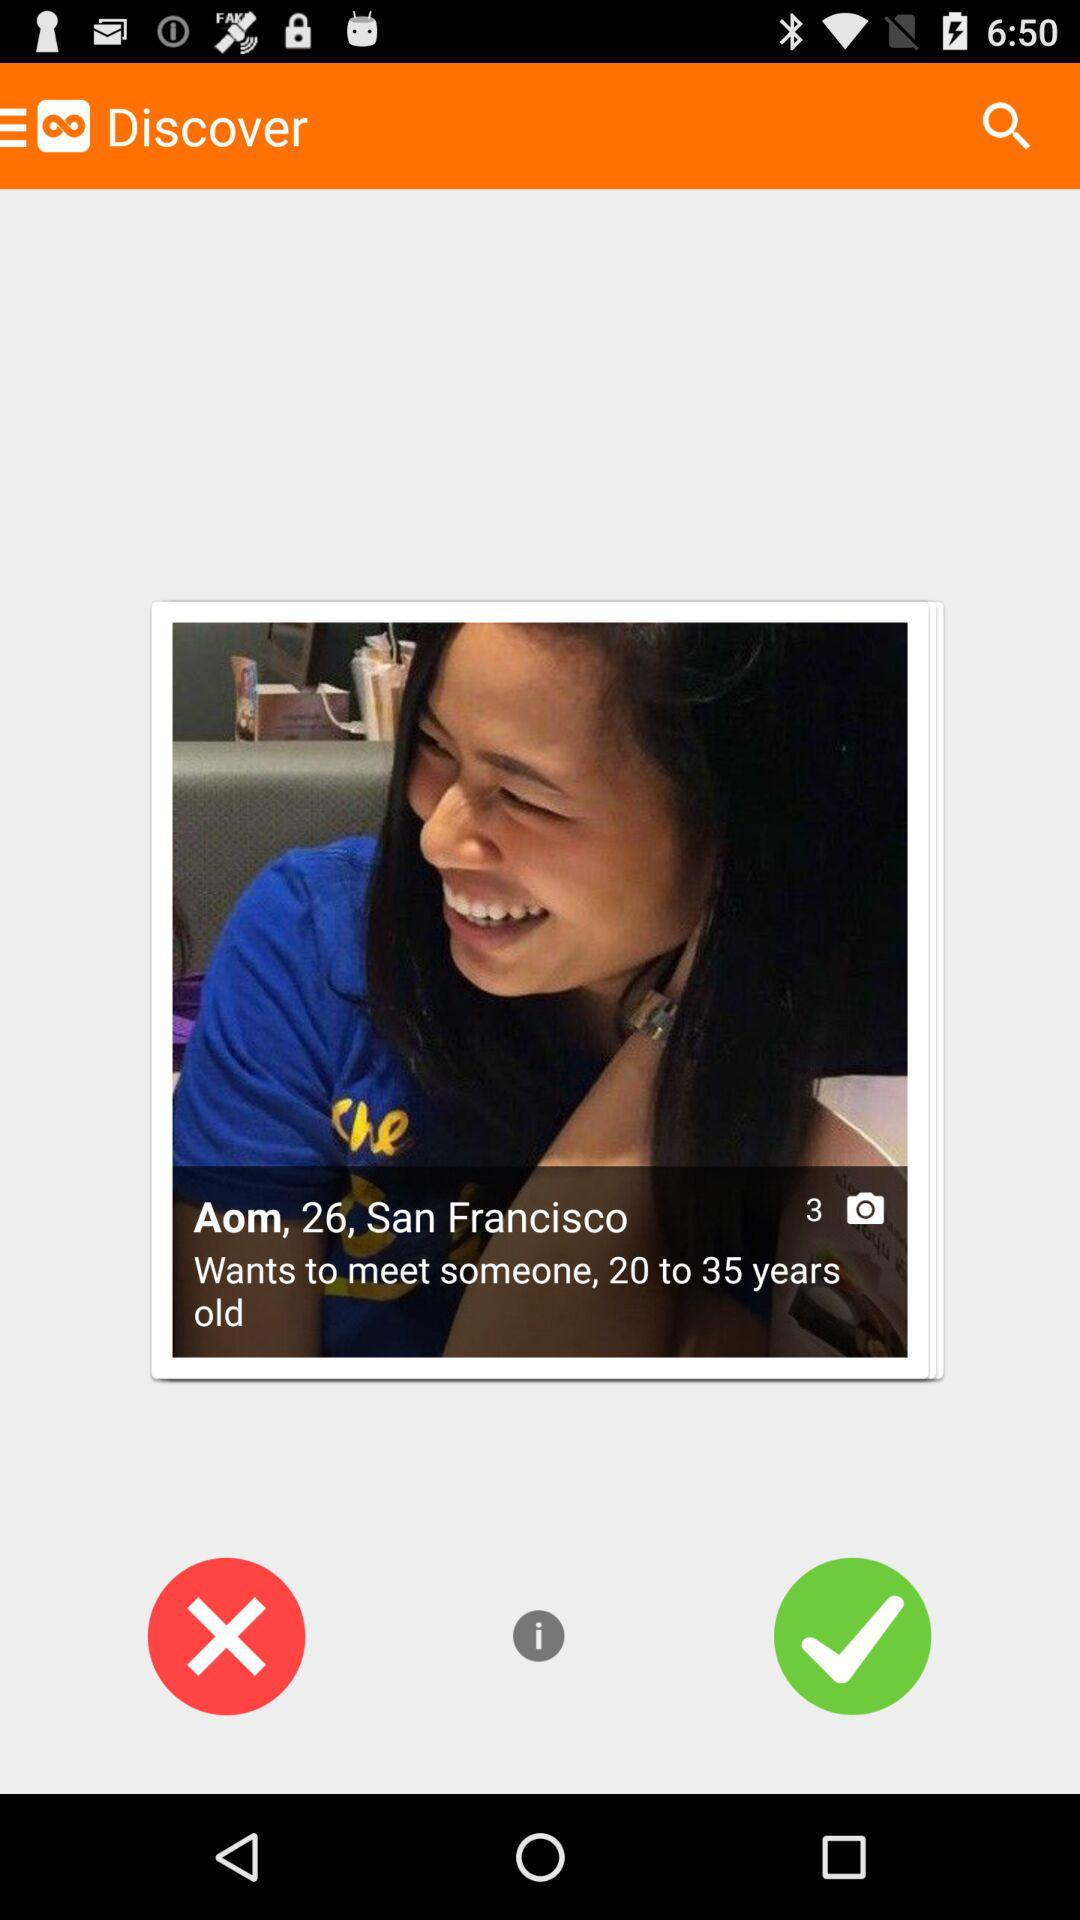What is the location? The location is San Francisco. 